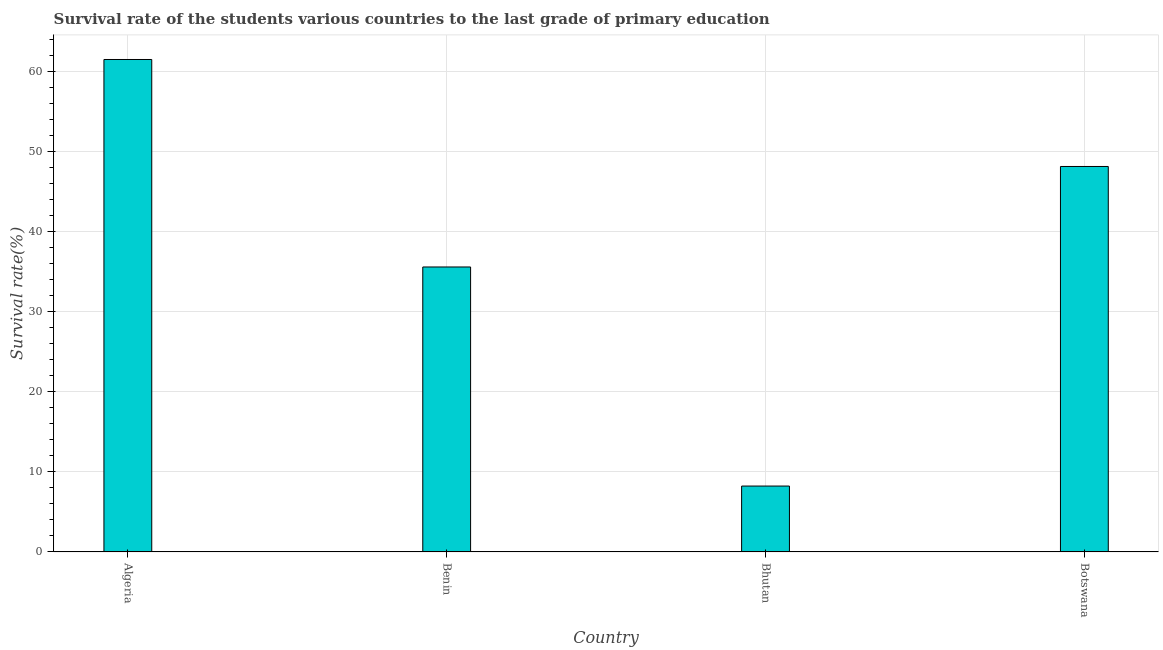What is the title of the graph?
Your answer should be compact. Survival rate of the students various countries to the last grade of primary education. What is the label or title of the X-axis?
Provide a succinct answer. Country. What is the label or title of the Y-axis?
Provide a succinct answer. Survival rate(%). What is the survival rate in primary education in Bhutan?
Give a very brief answer. 8.22. Across all countries, what is the maximum survival rate in primary education?
Give a very brief answer. 61.46. Across all countries, what is the minimum survival rate in primary education?
Your answer should be compact. 8.22. In which country was the survival rate in primary education maximum?
Offer a terse response. Algeria. In which country was the survival rate in primary education minimum?
Keep it short and to the point. Bhutan. What is the sum of the survival rate in primary education?
Make the answer very short. 153.35. What is the difference between the survival rate in primary education in Benin and Bhutan?
Your answer should be very brief. 27.34. What is the average survival rate in primary education per country?
Give a very brief answer. 38.34. What is the median survival rate in primary education?
Provide a succinct answer. 41.84. What is the ratio of the survival rate in primary education in Benin to that in Bhutan?
Your response must be concise. 4.33. Is the survival rate in primary education in Algeria less than that in Botswana?
Your answer should be compact. No. What is the difference between the highest and the second highest survival rate in primary education?
Make the answer very short. 13.35. What is the difference between the highest and the lowest survival rate in primary education?
Your response must be concise. 53.24. In how many countries, is the survival rate in primary education greater than the average survival rate in primary education taken over all countries?
Your response must be concise. 2. What is the Survival rate(%) in Algeria?
Offer a very short reply. 61.46. What is the Survival rate(%) of Benin?
Your answer should be compact. 35.56. What is the Survival rate(%) in Bhutan?
Offer a terse response. 8.22. What is the Survival rate(%) of Botswana?
Give a very brief answer. 48.11. What is the difference between the Survival rate(%) in Algeria and Benin?
Offer a terse response. 25.9. What is the difference between the Survival rate(%) in Algeria and Bhutan?
Make the answer very short. 53.24. What is the difference between the Survival rate(%) in Algeria and Botswana?
Make the answer very short. 13.35. What is the difference between the Survival rate(%) in Benin and Bhutan?
Your answer should be very brief. 27.34. What is the difference between the Survival rate(%) in Benin and Botswana?
Your response must be concise. -12.54. What is the difference between the Survival rate(%) in Bhutan and Botswana?
Your answer should be very brief. -39.89. What is the ratio of the Survival rate(%) in Algeria to that in Benin?
Provide a short and direct response. 1.73. What is the ratio of the Survival rate(%) in Algeria to that in Bhutan?
Your response must be concise. 7.48. What is the ratio of the Survival rate(%) in Algeria to that in Botswana?
Provide a succinct answer. 1.28. What is the ratio of the Survival rate(%) in Benin to that in Bhutan?
Provide a short and direct response. 4.33. What is the ratio of the Survival rate(%) in Benin to that in Botswana?
Your answer should be very brief. 0.74. What is the ratio of the Survival rate(%) in Bhutan to that in Botswana?
Give a very brief answer. 0.17. 